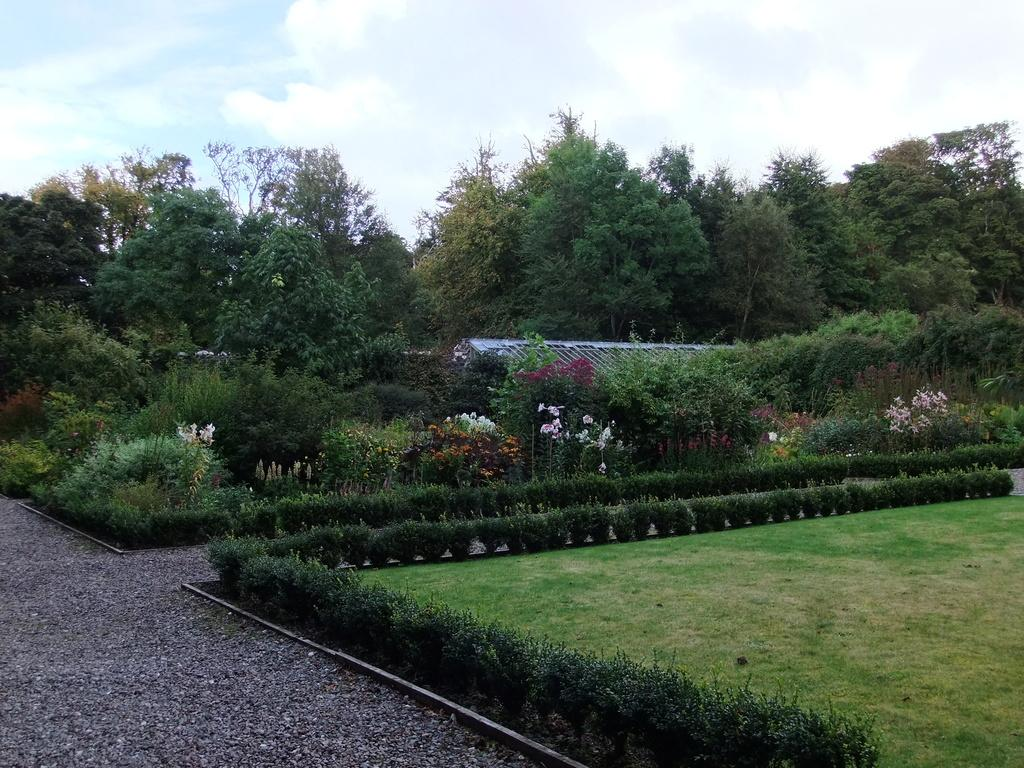What type of vegetation can be seen in the image? There are trees and bushes in the image. What type of structure is present in the image? There is a shed in the image. What is visible in the background of the image? The sky is visible in the background of the image. Can you see any gold objects in the image? There is no mention of any gold objects in the image. Is there a seashore visible in the image? There is no mention of a seashore in the image. 